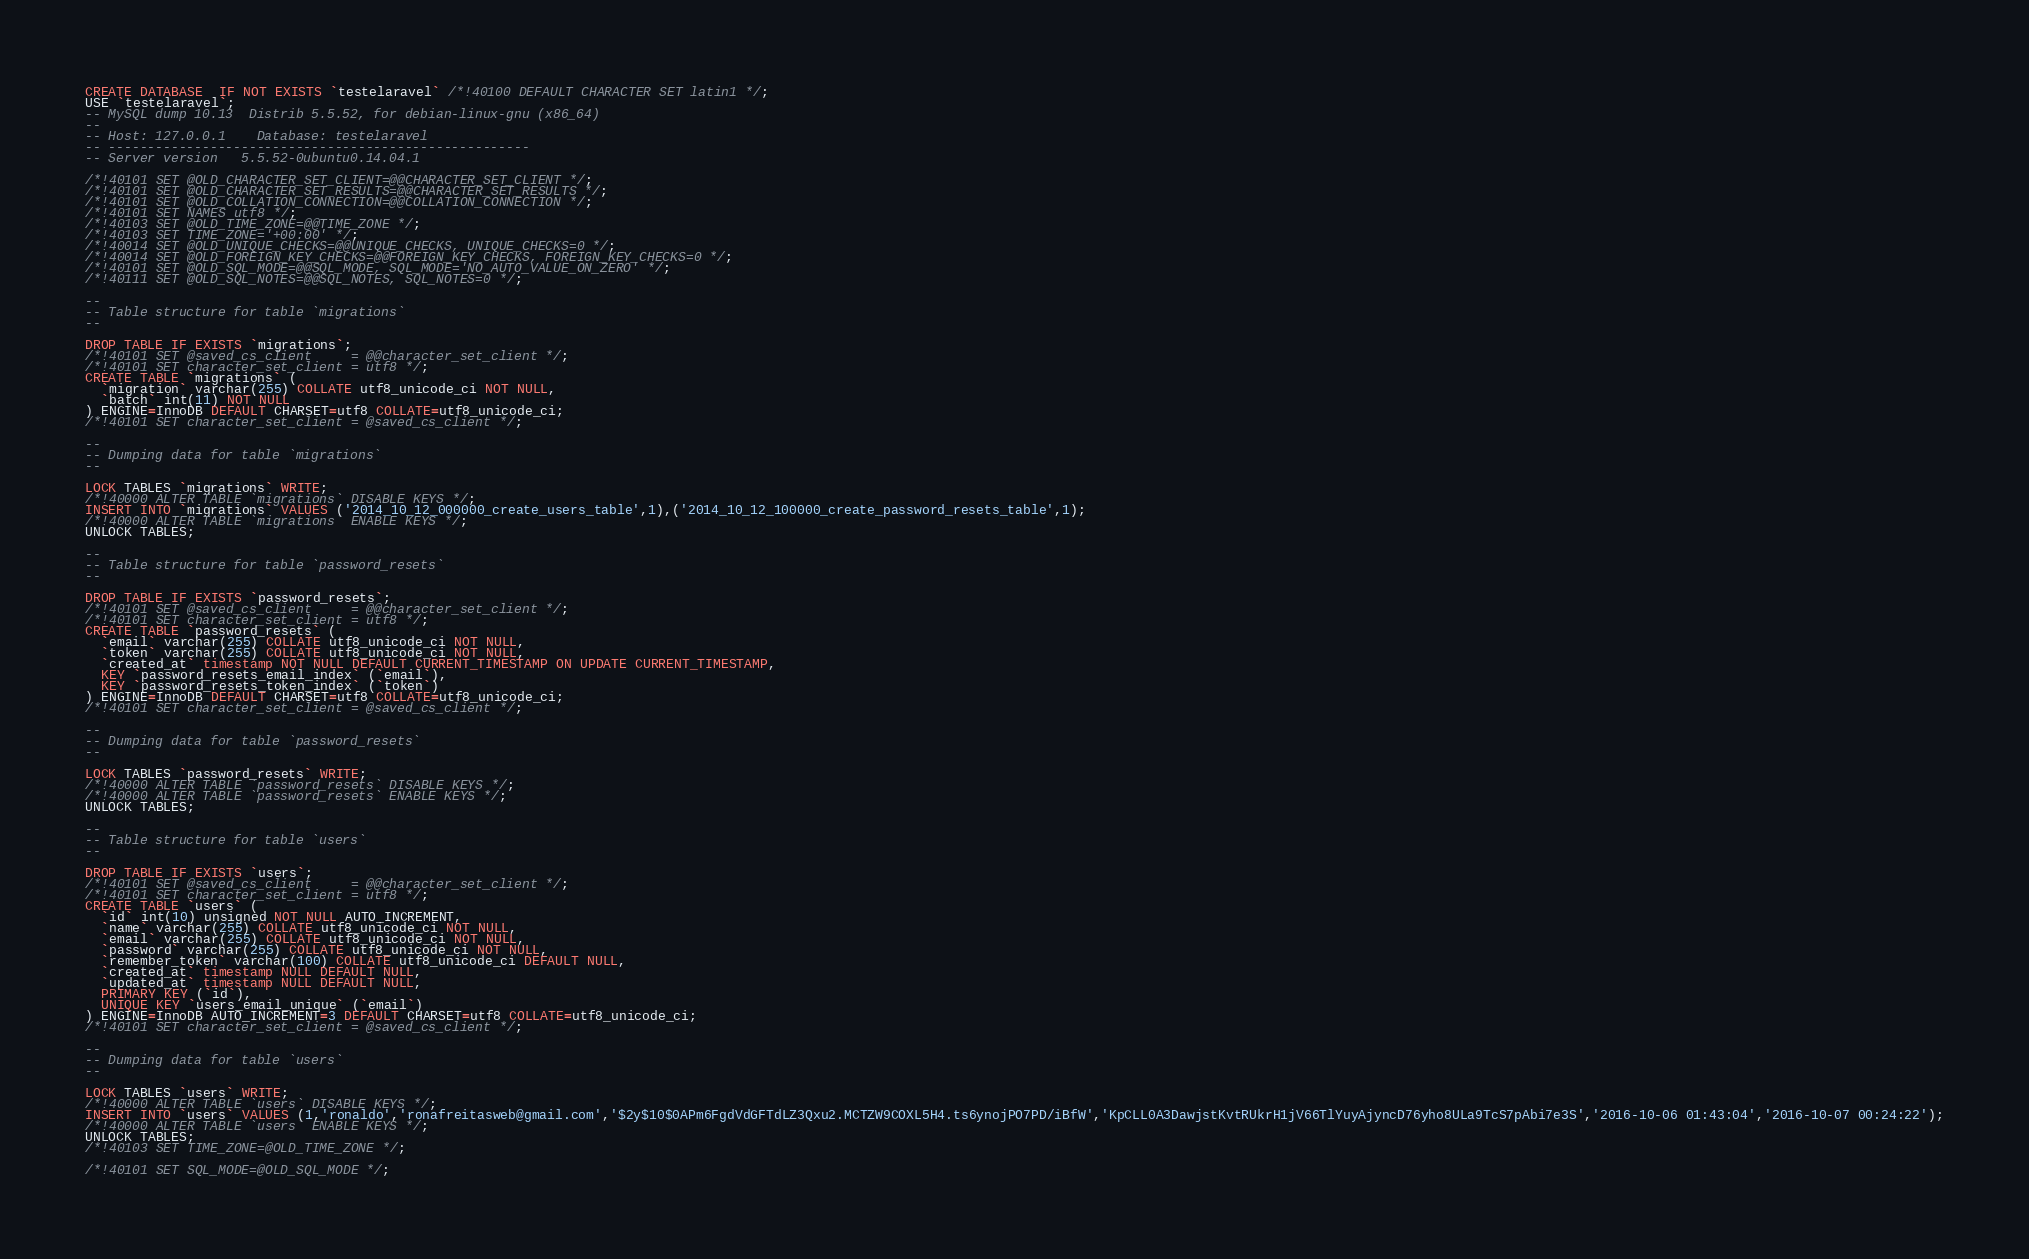<code> <loc_0><loc_0><loc_500><loc_500><_SQL_>CREATE DATABASE  IF NOT EXISTS `testelaravel` /*!40100 DEFAULT CHARACTER SET latin1 */;
USE `testelaravel`;
-- MySQL dump 10.13  Distrib 5.5.52, for debian-linux-gnu (x86_64)
--
-- Host: 127.0.0.1    Database: testelaravel
-- ------------------------------------------------------
-- Server version	5.5.52-0ubuntu0.14.04.1

/*!40101 SET @OLD_CHARACTER_SET_CLIENT=@@CHARACTER_SET_CLIENT */;
/*!40101 SET @OLD_CHARACTER_SET_RESULTS=@@CHARACTER_SET_RESULTS */;
/*!40101 SET @OLD_COLLATION_CONNECTION=@@COLLATION_CONNECTION */;
/*!40101 SET NAMES utf8 */;
/*!40103 SET @OLD_TIME_ZONE=@@TIME_ZONE */;
/*!40103 SET TIME_ZONE='+00:00' */;
/*!40014 SET @OLD_UNIQUE_CHECKS=@@UNIQUE_CHECKS, UNIQUE_CHECKS=0 */;
/*!40014 SET @OLD_FOREIGN_KEY_CHECKS=@@FOREIGN_KEY_CHECKS, FOREIGN_KEY_CHECKS=0 */;
/*!40101 SET @OLD_SQL_MODE=@@SQL_MODE, SQL_MODE='NO_AUTO_VALUE_ON_ZERO' */;
/*!40111 SET @OLD_SQL_NOTES=@@SQL_NOTES, SQL_NOTES=0 */;

--
-- Table structure for table `migrations`
--

DROP TABLE IF EXISTS `migrations`;
/*!40101 SET @saved_cs_client     = @@character_set_client */;
/*!40101 SET character_set_client = utf8 */;
CREATE TABLE `migrations` (
  `migration` varchar(255) COLLATE utf8_unicode_ci NOT NULL,
  `batch` int(11) NOT NULL
) ENGINE=InnoDB DEFAULT CHARSET=utf8 COLLATE=utf8_unicode_ci;
/*!40101 SET character_set_client = @saved_cs_client */;

--
-- Dumping data for table `migrations`
--

LOCK TABLES `migrations` WRITE;
/*!40000 ALTER TABLE `migrations` DISABLE KEYS */;
INSERT INTO `migrations` VALUES ('2014_10_12_000000_create_users_table',1),('2014_10_12_100000_create_password_resets_table',1);
/*!40000 ALTER TABLE `migrations` ENABLE KEYS */;
UNLOCK TABLES;

--
-- Table structure for table `password_resets`
--

DROP TABLE IF EXISTS `password_resets`;
/*!40101 SET @saved_cs_client     = @@character_set_client */;
/*!40101 SET character_set_client = utf8 */;
CREATE TABLE `password_resets` (
  `email` varchar(255) COLLATE utf8_unicode_ci NOT NULL,
  `token` varchar(255) COLLATE utf8_unicode_ci NOT NULL,
  `created_at` timestamp NOT NULL DEFAULT CURRENT_TIMESTAMP ON UPDATE CURRENT_TIMESTAMP,
  KEY `password_resets_email_index` (`email`),
  KEY `password_resets_token_index` (`token`)
) ENGINE=InnoDB DEFAULT CHARSET=utf8 COLLATE=utf8_unicode_ci;
/*!40101 SET character_set_client = @saved_cs_client */;

--
-- Dumping data for table `password_resets`
--

LOCK TABLES `password_resets` WRITE;
/*!40000 ALTER TABLE `password_resets` DISABLE KEYS */;
/*!40000 ALTER TABLE `password_resets` ENABLE KEYS */;
UNLOCK TABLES;

--
-- Table structure for table `users`
--

DROP TABLE IF EXISTS `users`;
/*!40101 SET @saved_cs_client     = @@character_set_client */;
/*!40101 SET character_set_client = utf8 */;
CREATE TABLE `users` (
  `id` int(10) unsigned NOT NULL AUTO_INCREMENT,
  `name` varchar(255) COLLATE utf8_unicode_ci NOT NULL,
  `email` varchar(255) COLLATE utf8_unicode_ci NOT NULL,
  `password` varchar(255) COLLATE utf8_unicode_ci NOT NULL,
  `remember_token` varchar(100) COLLATE utf8_unicode_ci DEFAULT NULL,
  `created_at` timestamp NULL DEFAULT NULL,
  `updated_at` timestamp NULL DEFAULT NULL,
  PRIMARY KEY (`id`),
  UNIQUE KEY `users_email_unique` (`email`)
) ENGINE=InnoDB AUTO_INCREMENT=3 DEFAULT CHARSET=utf8 COLLATE=utf8_unicode_ci;
/*!40101 SET character_set_client = @saved_cs_client */;

--
-- Dumping data for table `users`
--

LOCK TABLES `users` WRITE;
/*!40000 ALTER TABLE `users` DISABLE KEYS */;
INSERT INTO `users` VALUES (1,'ronaldo','ronafreitasweb@gmail.com','$2y$10$0APm6FgdVdGFTdLZ3Qxu2.MCTZW9COXL5H4.ts6ynojPO7PD/iBfW','KpCLL0A3DawjstKvtRUkrH1jV66TlYuyAjyncD76yho8ULa9TcS7pAbi7e3S','2016-10-06 01:43:04','2016-10-07 00:24:22');
/*!40000 ALTER TABLE `users` ENABLE KEYS */;
UNLOCK TABLES;
/*!40103 SET TIME_ZONE=@OLD_TIME_ZONE */;

/*!40101 SET SQL_MODE=@OLD_SQL_MODE */;</code> 